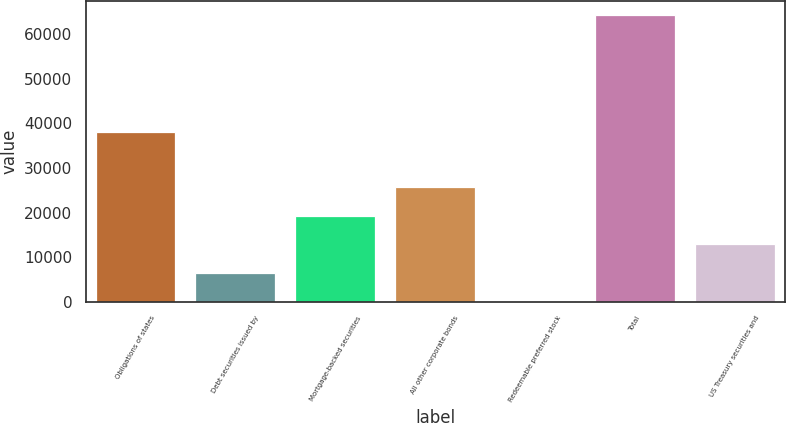Convert chart. <chart><loc_0><loc_0><loc_500><loc_500><bar_chart><fcel>Obligations of states<fcel>Debt securities issued by<fcel>Mortgage-backed securities<fcel>All other corporate bonds<fcel>Redeemable preferred stock<fcel>Total<fcel>US Treasury securities and<nl><fcel>38111<fcel>6498<fcel>19310<fcel>25716<fcel>92<fcel>64152<fcel>12904<nl></chart> 